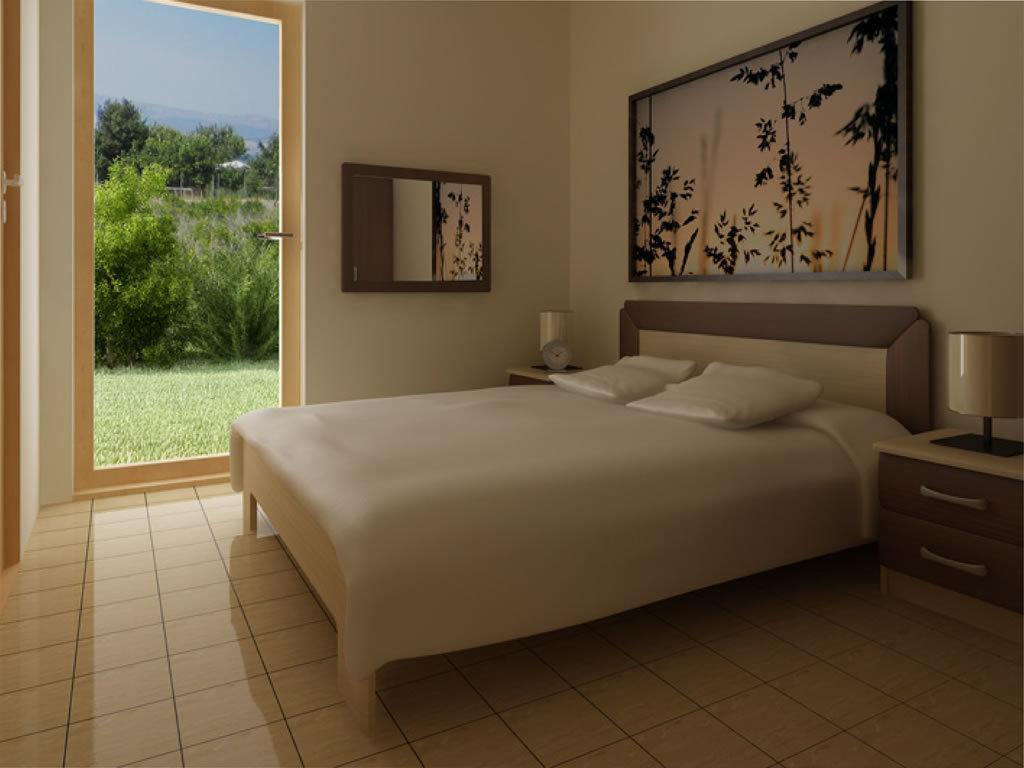Can you describe this image briefly? This is a door. We can can see sky, trees and a grass. This is a floor. Here we can see a bed with bed sheet and pillow and on the table we can see bed lamps and a clock. Here we can see a photo frame over a wall. 